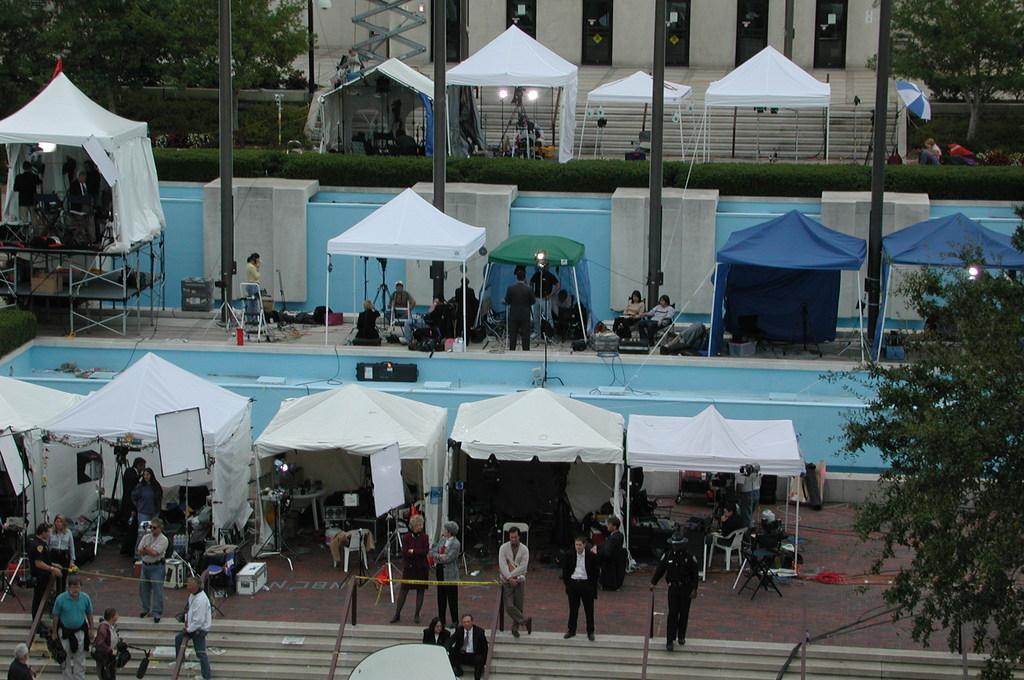How would you summarize this image in a sentence or two? In this image I can see group of people standing and I can see few lights, tents in white, green and blue color. In the background I can see few trees in green color and the building is in cream color. 